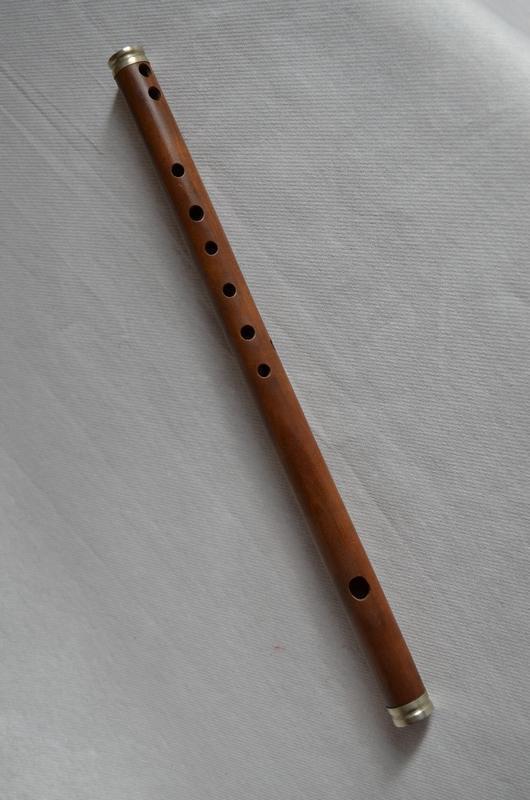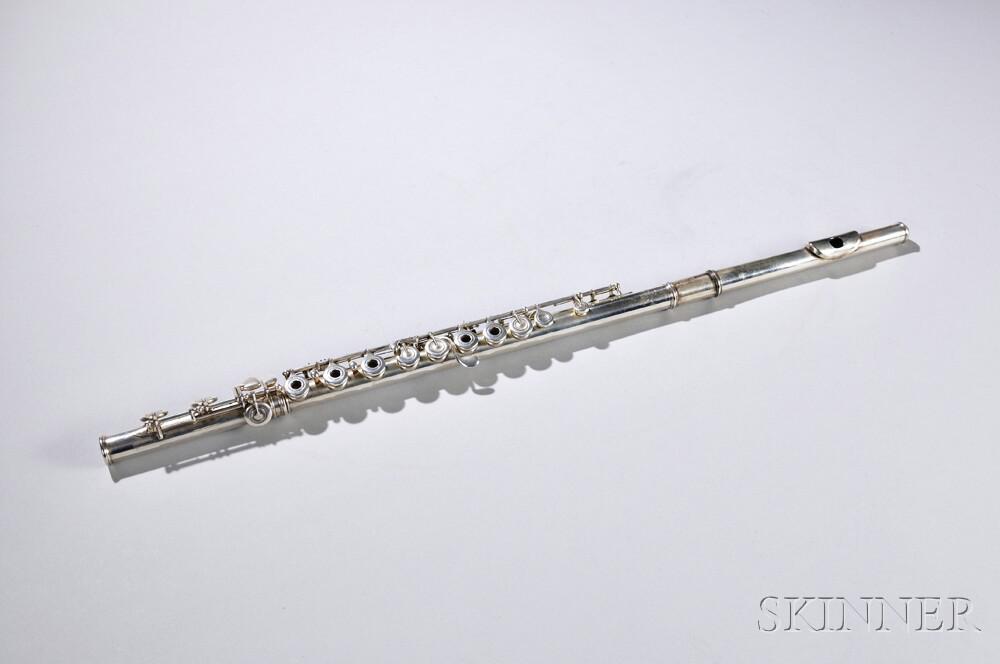The first image is the image on the left, the second image is the image on the right. Evaluate the accuracy of this statement regarding the images: "No image contains more than one instrument, and one instrument is light wood with holes down its length, and the other is silver with small button-keys on tabs.". Is it true? Answer yes or no. Yes. The first image is the image on the left, the second image is the image on the right. For the images shown, is this caption "The left image contains at least two musical instruments." true? Answer yes or no. No. 